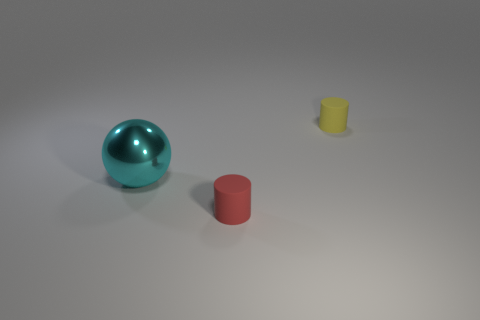What number of things are matte things that are in front of the ball or tiny cylinders that are in front of the large shiny ball?
Keep it short and to the point. 1. There is a rubber cylinder behind the large cyan sphere; what number of objects are in front of it?
Keep it short and to the point. 2. Does the tiny rubber object that is right of the red thing have the same shape as the matte thing in front of the large cyan metal thing?
Provide a succinct answer. Yes. Is there another purple ball made of the same material as the sphere?
Ensure brevity in your answer.  No. How many metallic objects are either small objects or big cyan things?
Make the answer very short. 1. There is a rubber thing in front of the matte cylinder behind the sphere; what shape is it?
Provide a succinct answer. Cylinder. Is the number of tiny cylinders that are on the left side of the yellow thing less than the number of small cyan cubes?
Provide a short and direct response. No. There is a big metal object; what shape is it?
Your response must be concise. Sphere. There is a cyan sphere that is in front of the yellow rubber thing; how big is it?
Make the answer very short. Large. What is the color of the rubber cylinder that is the same size as the red thing?
Provide a short and direct response. Yellow. 